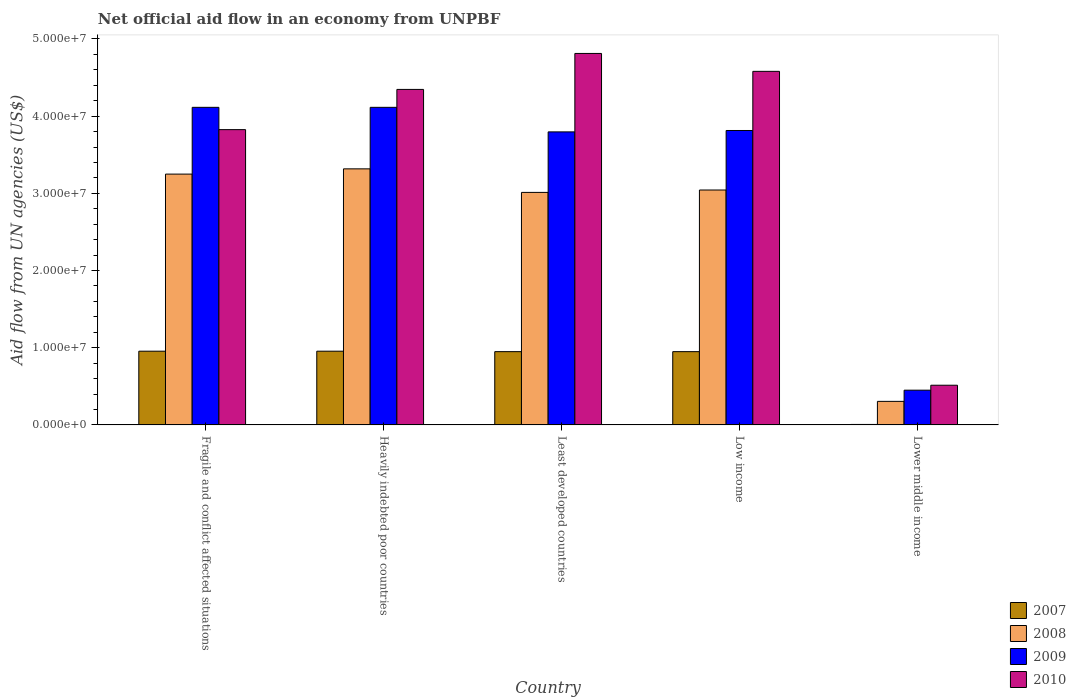How many different coloured bars are there?
Give a very brief answer. 4. How many groups of bars are there?
Offer a very short reply. 5. Are the number of bars per tick equal to the number of legend labels?
Make the answer very short. Yes. Are the number of bars on each tick of the X-axis equal?
Your response must be concise. Yes. What is the label of the 2nd group of bars from the left?
Offer a terse response. Heavily indebted poor countries. What is the net official aid flow in 2008 in Fragile and conflict affected situations?
Ensure brevity in your answer.  3.25e+07. Across all countries, what is the maximum net official aid flow in 2007?
Keep it short and to the point. 9.55e+06. Across all countries, what is the minimum net official aid flow in 2009?
Your answer should be compact. 4.50e+06. In which country was the net official aid flow in 2007 maximum?
Your response must be concise. Fragile and conflict affected situations. In which country was the net official aid flow in 2008 minimum?
Your answer should be very brief. Lower middle income. What is the total net official aid flow in 2010 in the graph?
Make the answer very short. 1.81e+08. What is the difference between the net official aid flow in 2008 in Heavily indebted poor countries and the net official aid flow in 2007 in Low income?
Give a very brief answer. 2.37e+07. What is the average net official aid flow in 2009 per country?
Provide a short and direct response. 3.26e+07. What is the difference between the net official aid flow of/in 2007 and net official aid flow of/in 2008 in Least developed countries?
Provide a short and direct response. -2.06e+07. In how many countries, is the net official aid flow in 2008 greater than 14000000 US$?
Provide a succinct answer. 4. What is the ratio of the net official aid flow in 2007 in Heavily indebted poor countries to that in Least developed countries?
Your answer should be compact. 1.01. Is the net official aid flow in 2009 in Heavily indebted poor countries less than that in Lower middle income?
Your answer should be compact. No. Is the difference between the net official aid flow in 2007 in Least developed countries and Lower middle income greater than the difference between the net official aid flow in 2008 in Least developed countries and Lower middle income?
Give a very brief answer. No. What is the difference between the highest and the second highest net official aid flow in 2010?
Provide a succinct answer. 2.32e+06. What is the difference between the highest and the lowest net official aid flow in 2009?
Your answer should be very brief. 3.66e+07. Is the sum of the net official aid flow in 2010 in Fragile and conflict affected situations and Heavily indebted poor countries greater than the maximum net official aid flow in 2009 across all countries?
Keep it short and to the point. Yes. What does the 4th bar from the right in Low income represents?
Provide a succinct answer. 2007. How many bars are there?
Your answer should be very brief. 20. How many countries are there in the graph?
Make the answer very short. 5. What is the difference between two consecutive major ticks on the Y-axis?
Your answer should be compact. 1.00e+07. Are the values on the major ticks of Y-axis written in scientific E-notation?
Make the answer very short. Yes. Does the graph contain any zero values?
Provide a short and direct response. No. How many legend labels are there?
Your answer should be very brief. 4. What is the title of the graph?
Your response must be concise. Net official aid flow in an economy from UNPBF. What is the label or title of the X-axis?
Give a very brief answer. Country. What is the label or title of the Y-axis?
Give a very brief answer. Aid flow from UN agencies (US$). What is the Aid flow from UN agencies (US$) in 2007 in Fragile and conflict affected situations?
Your response must be concise. 9.55e+06. What is the Aid flow from UN agencies (US$) of 2008 in Fragile and conflict affected situations?
Ensure brevity in your answer.  3.25e+07. What is the Aid flow from UN agencies (US$) of 2009 in Fragile and conflict affected situations?
Ensure brevity in your answer.  4.11e+07. What is the Aid flow from UN agencies (US$) in 2010 in Fragile and conflict affected situations?
Make the answer very short. 3.82e+07. What is the Aid flow from UN agencies (US$) of 2007 in Heavily indebted poor countries?
Your answer should be very brief. 9.55e+06. What is the Aid flow from UN agencies (US$) of 2008 in Heavily indebted poor countries?
Your answer should be compact. 3.32e+07. What is the Aid flow from UN agencies (US$) of 2009 in Heavily indebted poor countries?
Offer a terse response. 4.11e+07. What is the Aid flow from UN agencies (US$) in 2010 in Heavily indebted poor countries?
Provide a short and direct response. 4.35e+07. What is the Aid flow from UN agencies (US$) in 2007 in Least developed countries?
Offer a very short reply. 9.49e+06. What is the Aid flow from UN agencies (US$) in 2008 in Least developed countries?
Your response must be concise. 3.01e+07. What is the Aid flow from UN agencies (US$) of 2009 in Least developed countries?
Provide a short and direct response. 3.80e+07. What is the Aid flow from UN agencies (US$) of 2010 in Least developed countries?
Offer a terse response. 4.81e+07. What is the Aid flow from UN agencies (US$) of 2007 in Low income?
Offer a very short reply. 9.49e+06. What is the Aid flow from UN agencies (US$) of 2008 in Low income?
Keep it short and to the point. 3.04e+07. What is the Aid flow from UN agencies (US$) of 2009 in Low income?
Give a very brief answer. 3.81e+07. What is the Aid flow from UN agencies (US$) of 2010 in Low income?
Offer a terse response. 4.58e+07. What is the Aid flow from UN agencies (US$) in 2008 in Lower middle income?
Offer a very short reply. 3.05e+06. What is the Aid flow from UN agencies (US$) in 2009 in Lower middle income?
Offer a very short reply. 4.50e+06. What is the Aid flow from UN agencies (US$) of 2010 in Lower middle income?
Make the answer very short. 5.14e+06. Across all countries, what is the maximum Aid flow from UN agencies (US$) in 2007?
Provide a short and direct response. 9.55e+06. Across all countries, what is the maximum Aid flow from UN agencies (US$) of 2008?
Offer a very short reply. 3.32e+07. Across all countries, what is the maximum Aid flow from UN agencies (US$) in 2009?
Your answer should be compact. 4.11e+07. Across all countries, what is the maximum Aid flow from UN agencies (US$) of 2010?
Your response must be concise. 4.81e+07. Across all countries, what is the minimum Aid flow from UN agencies (US$) in 2008?
Your response must be concise. 3.05e+06. Across all countries, what is the minimum Aid flow from UN agencies (US$) of 2009?
Give a very brief answer. 4.50e+06. Across all countries, what is the minimum Aid flow from UN agencies (US$) in 2010?
Your response must be concise. 5.14e+06. What is the total Aid flow from UN agencies (US$) in 2007 in the graph?
Keep it short and to the point. 3.81e+07. What is the total Aid flow from UN agencies (US$) of 2008 in the graph?
Your answer should be very brief. 1.29e+08. What is the total Aid flow from UN agencies (US$) of 2009 in the graph?
Provide a short and direct response. 1.63e+08. What is the total Aid flow from UN agencies (US$) of 2010 in the graph?
Your answer should be very brief. 1.81e+08. What is the difference between the Aid flow from UN agencies (US$) in 2008 in Fragile and conflict affected situations and that in Heavily indebted poor countries?
Your answer should be very brief. -6.80e+05. What is the difference between the Aid flow from UN agencies (US$) of 2009 in Fragile and conflict affected situations and that in Heavily indebted poor countries?
Offer a terse response. 0. What is the difference between the Aid flow from UN agencies (US$) of 2010 in Fragile and conflict affected situations and that in Heavily indebted poor countries?
Keep it short and to the point. -5.21e+06. What is the difference between the Aid flow from UN agencies (US$) in 2008 in Fragile and conflict affected situations and that in Least developed countries?
Ensure brevity in your answer.  2.37e+06. What is the difference between the Aid flow from UN agencies (US$) in 2009 in Fragile and conflict affected situations and that in Least developed countries?
Make the answer very short. 3.18e+06. What is the difference between the Aid flow from UN agencies (US$) in 2010 in Fragile and conflict affected situations and that in Least developed countries?
Keep it short and to the point. -9.87e+06. What is the difference between the Aid flow from UN agencies (US$) in 2007 in Fragile and conflict affected situations and that in Low income?
Your response must be concise. 6.00e+04. What is the difference between the Aid flow from UN agencies (US$) in 2008 in Fragile and conflict affected situations and that in Low income?
Give a very brief answer. 2.06e+06. What is the difference between the Aid flow from UN agencies (US$) in 2009 in Fragile and conflict affected situations and that in Low income?
Keep it short and to the point. 3.00e+06. What is the difference between the Aid flow from UN agencies (US$) of 2010 in Fragile and conflict affected situations and that in Low income?
Offer a very short reply. -7.55e+06. What is the difference between the Aid flow from UN agencies (US$) of 2007 in Fragile and conflict affected situations and that in Lower middle income?
Your answer should be very brief. 9.49e+06. What is the difference between the Aid flow from UN agencies (US$) in 2008 in Fragile and conflict affected situations and that in Lower middle income?
Make the answer very short. 2.94e+07. What is the difference between the Aid flow from UN agencies (US$) in 2009 in Fragile and conflict affected situations and that in Lower middle income?
Your answer should be compact. 3.66e+07. What is the difference between the Aid flow from UN agencies (US$) in 2010 in Fragile and conflict affected situations and that in Lower middle income?
Make the answer very short. 3.31e+07. What is the difference between the Aid flow from UN agencies (US$) of 2008 in Heavily indebted poor countries and that in Least developed countries?
Make the answer very short. 3.05e+06. What is the difference between the Aid flow from UN agencies (US$) in 2009 in Heavily indebted poor countries and that in Least developed countries?
Ensure brevity in your answer.  3.18e+06. What is the difference between the Aid flow from UN agencies (US$) in 2010 in Heavily indebted poor countries and that in Least developed countries?
Give a very brief answer. -4.66e+06. What is the difference between the Aid flow from UN agencies (US$) in 2007 in Heavily indebted poor countries and that in Low income?
Your response must be concise. 6.00e+04. What is the difference between the Aid flow from UN agencies (US$) of 2008 in Heavily indebted poor countries and that in Low income?
Your answer should be compact. 2.74e+06. What is the difference between the Aid flow from UN agencies (US$) in 2009 in Heavily indebted poor countries and that in Low income?
Give a very brief answer. 3.00e+06. What is the difference between the Aid flow from UN agencies (US$) in 2010 in Heavily indebted poor countries and that in Low income?
Offer a terse response. -2.34e+06. What is the difference between the Aid flow from UN agencies (US$) of 2007 in Heavily indebted poor countries and that in Lower middle income?
Your answer should be very brief. 9.49e+06. What is the difference between the Aid flow from UN agencies (US$) of 2008 in Heavily indebted poor countries and that in Lower middle income?
Offer a very short reply. 3.01e+07. What is the difference between the Aid flow from UN agencies (US$) of 2009 in Heavily indebted poor countries and that in Lower middle income?
Provide a short and direct response. 3.66e+07. What is the difference between the Aid flow from UN agencies (US$) in 2010 in Heavily indebted poor countries and that in Lower middle income?
Provide a succinct answer. 3.83e+07. What is the difference between the Aid flow from UN agencies (US$) in 2007 in Least developed countries and that in Low income?
Offer a very short reply. 0. What is the difference between the Aid flow from UN agencies (US$) of 2008 in Least developed countries and that in Low income?
Offer a terse response. -3.10e+05. What is the difference between the Aid flow from UN agencies (US$) in 2009 in Least developed countries and that in Low income?
Ensure brevity in your answer.  -1.80e+05. What is the difference between the Aid flow from UN agencies (US$) in 2010 in Least developed countries and that in Low income?
Make the answer very short. 2.32e+06. What is the difference between the Aid flow from UN agencies (US$) of 2007 in Least developed countries and that in Lower middle income?
Your response must be concise. 9.43e+06. What is the difference between the Aid flow from UN agencies (US$) in 2008 in Least developed countries and that in Lower middle income?
Your answer should be very brief. 2.71e+07. What is the difference between the Aid flow from UN agencies (US$) in 2009 in Least developed countries and that in Lower middle income?
Keep it short and to the point. 3.35e+07. What is the difference between the Aid flow from UN agencies (US$) in 2010 in Least developed countries and that in Lower middle income?
Offer a very short reply. 4.30e+07. What is the difference between the Aid flow from UN agencies (US$) of 2007 in Low income and that in Lower middle income?
Your answer should be compact. 9.43e+06. What is the difference between the Aid flow from UN agencies (US$) in 2008 in Low income and that in Lower middle income?
Offer a very short reply. 2.74e+07. What is the difference between the Aid flow from UN agencies (US$) of 2009 in Low income and that in Lower middle income?
Offer a terse response. 3.36e+07. What is the difference between the Aid flow from UN agencies (US$) of 2010 in Low income and that in Lower middle income?
Your answer should be very brief. 4.07e+07. What is the difference between the Aid flow from UN agencies (US$) in 2007 in Fragile and conflict affected situations and the Aid flow from UN agencies (US$) in 2008 in Heavily indebted poor countries?
Your answer should be very brief. -2.36e+07. What is the difference between the Aid flow from UN agencies (US$) in 2007 in Fragile and conflict affected situations and the Aid flow from UN agencies (US$) in 2009 in Heavily indebted poor countries?
Make the answer very short. -3.16e+07. What is the difference between the Aid flow from UN agencies (US$) of 2007 in Fragile and conflict affected situations and the Aid flow from UN agencies (US$) of 2010 in Heavily indebted poor countries?
Keep it short and to the point. -3.39e+07. What is the difference between the Aid flow from UN agencies (US$) of 2008 in Fragile and conflict affected situations and the Aid flow from UN agencies (US$) of 2009 in Heavily indebted poor countries?
Your answer should be very brief. -8.65e+06. What is the difference between the Aid flow from UN agencies (US$) of 2008 in Fragile and conflict affected situations and the Aid flow from UN agencies (US$) of 2010 in Heavily indebted poor countries?
Give a very brief answer. -1.10e+07. What is the difference between the Aid flow from UN agencies (US$) in 2009 in Fragile and conflict affected situations and the Aid flow from UN agencies (US$) in 2010 in Heavily indebted poor countries?
Provide a short and direct response. -2.32e+06. What is the difference between the Aid flow from UN agencies (US$) of 2007 in Fragile and conflict affected situations and the Aid flow from UN agencies (US$) of 2008 in Least developed countries?
Ensure brevity in your answer.  -2.06e+07. What is the difference between the Aid flow from UN agencies (US$) in 2007 in Fragile and conflict affected situations and the Aid flow from UN agencies (US$) in 2009 in Least developed countries?
Provide a short and direct response. -2.84e+07. What is the difference between the Aid flow from UN agencies (US$) in 2007 in Fragile and conflict affected situations and the Aid flow from UN agencies (US$) in 2010 in Least developed countries?
Provide a succinct answer. -3.86e+07. What is the difference between the Aid flow from UN agencies (US$) of 2008 in Fragile and conflict affected situations and the Aid flow from UN agencies (US$) of 2009 in Least developed countries?
Offer a very short reply. -5.47e+06. What is the difference between the Aid flow from UN agencies (US$) in 2008 in Fragile and conflict affected situations and the Aid flow from UN agencies (US$) in 2010 in Least developed countries?
Provide a short and direct response. -1.56e+07. What is the difference between the Aid flow from UN agencies (US$) of 2009 in Fragile and conflict affected situations and the Aid flow from UN agencies (US$) of 2010 in Least developed countries?
Offer a terse response. -6.98e+06. What is the difference between the Aid flow from UN agencies (US$) in 2007 in Fragile and conflict affected situations and the Aid flow from UN agencies (US$) in 2008 in Low income?
Your answer should be compact. -2.09e+07. What is the difference between the Aid flow from UN agencies (US$) in 2007 in Fragile and conflict affected situations and the Aid flow from UN agencies (US$) in 2009 in Low income?
Offer a terse response. -2.86e+07. What is the difference between the Aid flow from UN agencies (US$) in 2007 in Fragile and conflict affected situations and the Aid flow from UN agencies (US$) in 2010 in Low income?
Ensure brevity in your answer.  -3.62e+07. What is the difference between the Aid flow from UN agencies (US$) in 2008 in Fragile and conflict affected situations and the Aid flow from UN agencies (US$) in 2009 in Low income?
Provide a short and direct response. -5.65e+06. What is the difference between the Aid flow from UN agencies (US$) in 2008 in Fragile and conflict affected situations and the Aid flow from UN agencies (US$) in 2010 in Low income?
Your response must be concise. -1.33e+07. What is the difference between the Aid flow from UN agencies (US$) of 2009 in Fragile and conflict affected situations and the Aid flow from UN agencies (US$) of 2010 in Low income?
Make the answer very short. -4.66e+06. What is the difference between the Aid flow from UN agencies (US$) of 2007 in Fragile and conflict affected situations and the Aid flow from UN agencies (US$) of 2008 in Lower middle income?
Your response must be concise. 6.50e+06. What is the difference between the Aid flow from UN agencies (US$) of 2007 in Fragile and conflict affected situations and the Aid flow from UN agencies (US$) of 2009 in Lower middle income?
Provide a short and direct response. 5.05e+06. What is the difference between the Aid flow from UN agencies (US$) of 2007 in Fragile and conflict affected situations and the Aid flow from UN agencies (US$) of 2010 in Lower middle income?
Offer a very short reply. 4.41e+06. What is the difference between the Aid flow from UN agencies (US$) in 2008 in Fragile and conflict affected situations and the Aid flow from UN agencies (US$) in 2009 in Lower middle income?
Make the answer very short. 2.80e+07. What is the difference between the Aid flow from UN agencies (US$) of 2008 in Fragile and conflict affected situations and the Aid flow from UN agencies (US$) of 2010 in Lower middle income?
Make the answer very short. 2.74e+07. What is the difference between the Aid flow from UN agencies (US$) in 2009 in Fragile and conflict affected situations and the Aid flow from UN agencies (US$) in 2010 in Lower middle income?
Your answer should be compact. 3.60e+07. What is the difference between the Aid flow from UN agencies (US$) in 2007 in Heavily indebted poor countries and the Aid flow from UN agencies (US$) in 2008 in Least developed countries?
Make the answer very short. -2.06e+07. What is the difference between the Aid flow from UN agencies (US$) of 2007 in Heavily indebted poor countries and the Aid flow from UN agencies (US$) of 2009 in Least developed countries?
Give a very brief answer. -2.84e+07. What is the difference between the Aid flow from UN agencies (US$) of 2007 in Heavily indebted poor countries and the Aid flow from UN agencies (US$) of 2010 in Least developed countries?
Offer a terse response. -3.86e+07. What is the difference between the Aid flow from UN agencies (US$) in 2008 in Heavily indebted poor countries and the Aid flow from UN agencies (US$) in 2009 in Least developed countries?
Give a very brief answer. -4.79e+06. What is the difference between the Aid flow from UN agencies (US$) in 2008 in Heavily indebted poor countries and the Aid flow from UN agencies (US$) in 2010 in Least developed countries?
Keep it short and to the point. -1.50e+07. What is the difference between the Aid flow from UN agencies (US$) in 2009 in Heavily indebted poor countries and the Aid flow from UN agencies (US$) in 2010 in Least developed countries?
Ensure brevity in your answer.  -6.98e+06. What is the difference between the Aid flow from UN agencies (US$) in 2007 in Heavily indebted poor countries and the Aid flow from UN agencies (US$) in 2008 in Low income?
Make the answer very short. -2.09e+07. What is the difference between the Aid flow from UN agencies (US$) in 2007 in Heavily indebted poor countries and the Aid flow from UN agencies (US$) in 2009 in Low income?
Offer a terse response. -2.86e+07. What is the difference between the Aid flow from UN agencies (US$) of 2007 in Heavily indebted poor countries and the Aid flow from UN agencies (US$) of 2010 in Low income?
Make the answer very short. -3.62e+07. What is the difference between the Aid flow from UN agencies (US$) of 2008 in Heavily indebted poor countries and the Aid flow from UN agencies (US$) of 2009 in Low income?
Make the answer very short. -4.97e+06. What is the difference between the Aid flow from UN agencies (US$) in 2008 in Heavily indebted poor countries and the Aid flow from UN agencies (US$) in 2010 in Low income?
Offer a very short reply. -1.26e+07. What is the difference between the Aid flow from UN agencies (US$) of 2009 in Heavily indebted poor countries and the Aid flow from UN agencies (US$) of 2010 in Low income?
Keep it short and to the point. -4.66e+06. What is the difference between the Aid flow from UN agencies (US$) in 2007 in Heavily indebted poor countries and the Aid flow from UN agencies (US$) in 2008 in Lower middle income?
Your answer should be very brief. 6.50e+06. What is the difference between the Aid flow from UN agencies (US$) in 2007 in Heavily indebted poor countries and the Aid flow from UN agencies (US$) in 2009 in Lower middle income?
Provide a short and direct response. 5.05e+06. What is the difference between the Aid flow from UN agencies (US$) in 2007 in Heavily indebted poor countries and the Aid flow from UN agencies (US$) in 2010 in Lower middle income?
Make the answer very short. 4.41e+06. What is the difference between the Aid flow from UN agencies (US$) of 2008 in Heavily indebted poor countries and the Aid flow from UN agencies (US$) of 2009 in Lower middle income?
Offer a very short reply. 2.87e+07. What is the difference between the Aid flow from UN agencies (US$) in 2008 in Heavily indebted poor countries and the Aid flow from UN agencies (US$) in 2010 in Lower middle income?
Provide a succinct answer. 2.80e+07. What is the difference between the Aid flow from UN agencies (US$) of 2009 in Heavily indebted poor countries and the Aid flow from UN agencies (US$) of 2010 in Lower middle income?
Provide a short and direct response. 3.60e+07. What is the difference between the Aid flow from UN agencies (US$) of 2007 in Least developed countries and the Aid flow from UN agencies (US$) of 2008 in Low income?
Your answer should be very brief. -2.09e+07. What is the difference between the Aid flow from UN agencies (US$) of 2007 in Least developed countries and the Aid flow from UN agencies (US$) of 2009 in Low income?
Ensure brevity in your answer.  -2.86e+07. What is the difference between the Aid flow from UN agencies (US$) of 2007 in Least developed countries and the Aid flow from UN agencies (US$) of 2010 in Low income?
Your answer should be very brief. -3.63e+07. What is the difference between the Aid flow from UN agencies (US$) of 2008 in Least developed countries and the Aid flow from UN agencies (US$) of 2009 in Low income?
Provide a short and direct response. -8.02e+06. What is the difference between the Aid flow from UN agencies (US$) of 2008 in Least developed countries and the Aid flow from UN agencies (US$) of 2010 in Low income?
Your response must be concise. -1.57e+07. What is the difference between the Aid flow from UN agencies (US$) in 2009 in Least developed countries and the Aid flow from UN agencies (US$) in 2010 in Low income?
Provide a short and direct response. -7.84e+06. What is the difference between the Aid flow from UN agencies (US$) in 2007 in Least developed countries and the Aid flow from UN agencies (US$) in 2008 in Lower middle income?
Provide a succinct answer. 6.44e+06. What is the difference between the Aid flow from UN agencies (US$) of 2007 in Least developed countries and the Aid flow from UN agencies (US$) of 2009 in Lower middle income?
Keep it short and to the point. 4.99e+06. What is the difference between the Aid flow from UN agencies (US$) in 2007 in Least developed countries and the Aid flow from UN agencies (US$) in 2010 in Lower middle income?
Give a very brief answer. 4.35e+06. What is the difference between the Aid flow from UN agencies (US$) in 2008 in Least developed countries and the Aid flow from UN agencies (US$) in 2009 in Lower middle income?
Provide a short and direct response. 2.56e+07. What is the difference between the Aid flow from UN agencies (US$) in 2008 in Least developed countries and the Aid flow from UN agencies (US$) in 2010 in Lower middle income?
Your answer should be compact. 2.50e+07. What is the difference between the Aid flow from UN agencies (US$) in 2009 in Least developed countries and the Aid flow from UN agencies (US$) in 2010 in Lower middle income?
Offer a terse response. 3.28e+07. What is the difference between the Aid flow from UN agencies (US$) of 2007 in Low income and the Aid flow from UN agencies (US$) of 2008 in Lower middle income?
Make the answer very short. 6.44e+06. What is the difference between the Aid flow from UN agencies (US$) in 2007 in Low income and the Aid flow from UN agencies (US$) in 2009 in Lower middle income?
Offer a very short reply. 4.99e+06. What is the difference between the Aid flow from UN agencies (US$) in 2007 in Low income and the Aid flow from UN agencies (US$) in 2010 in Lower middle income?
Ensure brevity in your answer.  4.35e+06. What is the difference between the Aid flow from UN agencies (US$) in 2008 in Low income and the Aid flow from UN agencies (US$) in 2009 in Lower middle income?
Ensure brevity in your answer.  2.59e+07. What is the difference between the Aid flow from UN agencies (US$) of 2008 in Low income and the Aid flow from UN agencies (US$) of 2010 in Lower middle income?
Your answer should be very brief. 2.53e+07. What is the difference between the Aid flow from UN agencies (US$) in 2009 in Low income and the Aid flow from UN agencies (US$) in 2010 in Lower middle income?
Make the answer very short. 3.30e+07. What is the average Aid flow from UN agencies (US$) of 2007 per country?
Keep it short and to the point. 7.63e+06. What is the average Aid flow from UN agencies (US$) of 2008 per country?
Your response must be concise. 2.59e+07. What is the average Aid flow from UN agencies (US$) of 2009 per country?
Provide a succinct answer. 3.26e+07. What is the average Aid flow from UN agencies (US$) in 2010 per country?
Provide a succinct answer. 3.62e+07. What is the difference between the Aid flow from UN agencies (US$) in 2007 and Aid flow from UN agencies (US$) in 2008 in Fragile and conflict affected situations?
Offer a terse response. -2.29e+07. What is the difference between the Aid flow from UN agencies (US$) of 2007 and Aid flow from UN agencies (US$) of 2009 in Fragile and conflict affected situations?
Your answer should be compact. -3.16e+07. What is the difference between the Aid flow from UN agencies (US$) of 2007 and Aid flow from UN agencies (US$) of 2010 in Fragile and conflict affected situations?
Ensure brevity in your answer.  -2.87e+07. What is the difference between the Aid flow from UN agencies (US$) in 2008 and Aid flow from UN agencies (US$) in 2009 in Fragile and conflict affected situations?
Make the answer very short. -8.65e+06. What is the difference between the Aid flow from UN agencies (US$) in 2008 and Aid flow from UN agencies (US$) in 2010 in Fragile and conflict affected situations?
Your response must be concise. -5.76e+06. What is the difference between the Aid flow from UN agencies (US$) of 2009 and Aid flow from UN agencies (US$) of 2010 in Fragile and conflict affected situations?
Your response must be concise. 2.89e+06. What is the difference between the Aid flow from UN agencies (US$) in 2007 and Aid flow from UN agencies (US$) in 2008 in Heavily indebted poor countries?
Ensure brevity in your answer.  -2.36e+07. What is the difference between the Aid flow from UN agencies (US$) in 2007 and Aid flow from UN agencies (US$) in 2009 in Heavily indebted poor countries?
Keep it short and to the point. -3.16e+07. What is the difference between the Aid flow from UN agencies (US$) in 2007 and Aid flow from UN agencies (US$) in 2010 in Heavily indebted poor countries?
Your response must be concise. -3.39e+07. What is the difference between the Aid flow from UN agencies (US$) in 2008 and Aid flow from UN agencies (US$) in 2009 in Heavily indebted poor countries?
Offer a very short reply. -7.97e+06. What is the difference between the Aid flow from UN agencies (US$) of 2008 and Aid flow from UN agencies (US$) of 2010 in Heavily indebted poor countries?
Your response must be concise. -1.03e+07. What is the difference between the Aid flow from UN agencies (US$) in 2009 and Aid flow from UN agencies (US$) in 2010 in Heavily indebted poor countries?
Give a very brief answer. -2.32e+06. What is the difference between the Aid flow from UN agencies (US$) in 2007 and Aid flow from UN agencies (US$) in 2008 in Least developed countries?
Offer a very short reply. -2.06e+07. What is the difference between the Aid flow from UN agencies (US$) in 2007 and Aid flow from UN agencies (US$) in 2009 in Least developed countries?
Make the answer very short. -2.85e+07. What is the difference between the Aid flow from UN agencies (US$) of 2007 and Aid flow from UN agencies (US$) of 2010 in Least developed countries?
Ensure brevity in your answer.  -3.86e+07. What is the difference between the Aid flow from UN agencies (US$) in 2008 and Aid flow from UN agencies (US$) in 2009 in Least developed countries?
Provide a succinct answer. -7.84e+06. What is the difference between the Aid flow from UN agencies (US$) in 2008 and Aid flow from UN agencies (US$) in 2010 in Least developed countries?
Your answer should be very brief. -1.80e+07. What is the difference between the Aid flow from UN agencies (US$) of 2009 and Aid flow from UN agencies (US$) of 2010 in Least developed countries?
Keep it short and to the point. -1.02e+07. What is the difference between the Aid flow from UN agencies (US$) of 2007 and Aid flow from UN agencies (US$) of 2008 in Low income?
Offer a terse response. -2.09e+07. What is the difference between the Aid flow from UN agencies (US$) of 2007 and Aid flow from UN agencies (US$) of 2009 in Low income?
Give a very brief answer. -2.86e+07. What is the difference between the Aid flow from UN agencies (US$) of 2007 and Aid flow from UN agencies (US$) of 2010 in Low income?
Ensure brevity in your answer.  -3.63e+07. What is the difference between the Aid flow from UN agencies (US$) of 2008 and Aid flow from UN agencies (US$) of 2009 in Low income?
Your answer should be very brief. -7.71e+06. What is the difference between the Aid flow from UN agencies (US$) of 2008 and Aid flow from UN agencies (US$) of 2010 in Low income?
Provide a short and direct response. -1.54e+07. What is the difference between the Aid flow from UN agencies (US$) of 2009 and Aid flow from UN agencies (US$) of 2010 in Low income?
Provide a short and direct response. -7.66e+06. What is the difference between the Aid flow from UN agencies (US$) in 2007 and Aid flow from UN agencies (US$) in 2008 in Lower middle income?
Give a very brief answer. -2.99e+06. What is the difference between the Aid flow from UN agencies (US$) in 2007 and Aid flow from UN agencies (US$) in 2009 in Lower middle income?
Offer a very short reply. -4.44e+06. What is the difference between the Aid flow from UN agencies (US$) in 2007 and Aid flow from UN agencies (US$) in 2010 in Lower middle income?
Ensure brevity in your answer.  -5.08e+06. What is the difference between the Aid flow from UN agencies (US$) in 2008 and Aid flow from UN agencies (US$) in 2009 in Lower middle income?
Your response must be concise. -1.45e+06. What is the difference between the Aid flow from UN agencies (US$) of 2008 and Aid flow from UN agencies (US$) of 2010 in Lower middle income?
Make the answer very short. -2.09e+06. What is the difference between the Aid flow from UN agencies (US$) of 2009 and Aid flow from UN agencies (US$) of 2010 in Lower middle income?
Your answer should be compact. -6.40e+05. What is the ratio of the Aid flow from UN agencies (US$) of 2008 in Fragile and conflict affected situations to that in Heavily indebted poor countries?
Offer a very short reply. 0.98. What is the ratio of the Aid flow from UN agencies (US$) in 2009 in Fragile and conflict affected situations to that in Heavily indebted poor countries?
Offer a very short reply. 1. What is the ratio of the Aid flow from UN agencies (US$) in 2010 in Fragile and conflict affected situations to that in Heavily indebted poor countries?
Keep it short and to the point. 0.88. What is the ratio of the Aid flow from UN agencies (US$) in 2007 in Fragile and conflict affected situations to that in Least developed countries?
Your answer should be very brief. 1.01. What is the ratio of the Aid flow from UN agencies (US$) of 2008 in Fragile and conflict affected situations to that in Least developed countries?
Give a very brief answer. 1.08. What is the ratio of the Aid flow from UN agencies (US$) of 2009 in Fragile and conflict affected situations to that in Least developed countries?
Your answer should be very brief. 1.08. What is the ratio of the Aid flow from UN agencies (US$) in 2010 in Fragile and conflict affected situations to that in Least developed countries?
Provide a succinct answer. 0.79. What is the ratio of the Aid flow from UN agencies (US$) of 2007 in Fragile and conflict affected situations to that in Low income?
Offer a very short reply. 1.01. What is the ratio of the Aid flow from UN agencies (US$) of 2008 in Fragile and conflict affected situations to that in Low income?
Offer a terse response. 1.07. What is the ratio of the Aid flow from UN agencies (US$) of 2009 in Fragile and conflict affected situations to that in Low income?
Make the answer very short. 1.08. What is the ratio of the Aid flow from UN agencies (US$) of 2010 in Fragile and conflict affected situations to that in Low income?
Ensure brevity in your answer.  0.84. What is the ratio of the Aid flow from UN agencies (US$) in 2007 in Fragile and conflict affected situations to that in Lower middle income?
Your response must be concise. 159.17. What is the ratio of the Aid flow from UN agencies (US$) of 2008 in Fragile and conflict affected situations to that in Lower middle income?
Your response must be concise. 10.65. What is the ratio of the Aid flow from UN agencies (US$) in 2009 in Fragile and conflict affected situations to that in Lower middle income?
Your answer should be very brief. 9.14. What is the ratio of the Aid flow from UN agencies (US$) in 2010 in Fragile and conflict affected situations to that in Lower middle income?
Make the answer very short. 7.44. What is the ratio of the Aid flow from UN agencies (US$) in 2008 in Heavily indebted poor countries to that in Least developed countries?
Offer a terse response. 1.1. What is the ratio of the Aid flow from UN agencies (US$) in 2009 in Heavily indebted poor countries to that in Least developed countries?
Provide a short and direct response. 1.08. What is the ratio of the Aid flow from UN agencies (US$) in 2010 in Heavily indebted poor countries to that in Least developed countries?
Your response must be concise. 0.9. What is the ratio of the Aid flow from UN agencies (US$) of 2008 in Heavily indebted poor countries to that in Low income?
Your response must be concise. 1.09. What is the ratio of the Aid flow from UN agencies (US$) in 2009 in Heavily indebted poor countries to that in Low income?
Provide a short and direct response. 1.08. What is the ratio of the Aid flow from UN agencies (US$) of 2010 in Heavily indebted poor countries to that in Low income?
Provide a succinct answer. 0.95. What is the ratio of the Aid flow from UN agencies (US$) in 2007 in Heavily indebted poor countries to that in Lower middle income?
Your answer should be very brief. 159.17. What is the ratio of the Aid flow from UN agencies (US$) in 2008 in Heavily indebted poor countries to that in Lower middle income?
Your answer should be compact. 10.88. What is the ratio of the Aid flow from UN agencies (US$) of 2009 in Heavily indebted poor countries to that in Lower middle income?
Offer a terse response. 9.14. What is the ratio of the Aid flow from UN agencies (US$) in 2010 in Heavily indebted poor countries to that in Lower middle income?
Offer a very short reply. 8.46. What is the ratio of the Aid flow from UN agencies (US$) of 2007 in Least developed countries to that in Low income?
Your answer should be very brief. 1. What is the ratio of the Aid flow from UN agencies (US$) of 2010 in Least developed countries to that in Low income?
Give a very brief answer. 1.05. What is the ratio of the Aid flow from UN agencies (US$) of 2007 in Least developed countries to that in Lower middle income?
Offer a terse response. 158.17. What is the ratio of the Aid flow from UN agencies (US$) in 2008 in Least developed countries to that in Lower middle income?
Your response must be concise. 9.88. What is the ratio of the Aid flow from UN agencies (US$) in 2009 in Least developed countries to that in Lower middle income?
Offer a terse response. 8.44. What is the ratio of the Aid flow from UN agencies (US$) of 2010 in Least developed countries to that in Lower middle income?
Offer a very short reply. 9.36. What is the ratio of the Aid flow from UN agencies (US$) in 2007 in Low income to that in Lower middle income?
Ensure brevity in your answer.  158.17. What is the ratio of the Aid flow from UN agencies (US$) of 2008 in Low income to that in Lower middle income?
Make the answer very short. 9.98. What is the ratio of the Aid flow from UN agencies (US$) of 2009 in Low income to that in Lower middle income?
Ensure brevity in your answer.  8.48. What is the ratio of the Aid flow from UN agencies (US$) in 2010 in Low income to that in Lower middle income?
Ensure brevity in your answer.  8.91. What is the difference between the highest and the second highest Aid flow from UN agencies (US$) of 2007?
Keep it short and to the point. 0. What is the difference between the highest and the second highest Aid flow from UN agencies (US$) of 2008?
Ensure brevity in your answer.  6.80e+05. What is the difference between the highest and the second highest Aid flow from UN agencies (US$) of 2009?
Offer a terse response. 0. What is the difference between the highest and the second highest Aid flow from UN agencies (US$) of 2010?
Give a very brief answer. 2.32e+06. What is the difference between the highest and the lowest Aid flow from UN agencies (US$) in 2007?
Give a very brief answer. 9.49e+06. What is the difference between the highest and the lowest Aid flow from UN agencies (US$) of 2008?
Your answer should be very brief. 3.01e+07. What is the difference between the highest and the lowest Aid flow from UN agencies (US$) in 2009?
Your response must be concise. 3.66e+07. What is the difference between the highest and the lowest Aid flow from UN agencies (US$) in 2010?
Your answer should be compact. 4.30e+07. 